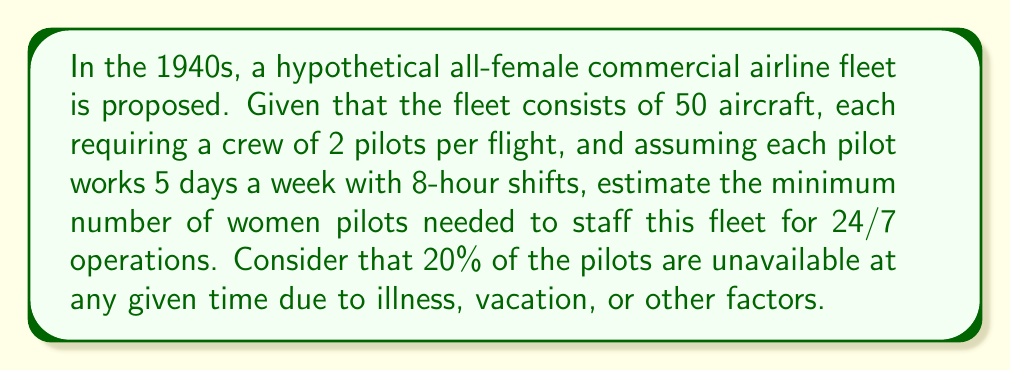Show me your answer to this math problem. 1. Calculate the total number of pilot positions per day:
   $$ \text{Total positions} = \text{Number of aircraft} \times \text{Pilots per aircraft} \times \text{Shifts per day} $$
   $$ \text{Total positions} = 50 \times 2 \times 3 = 300 \text{ positions per day} $$

2. Calculate the number of working days per week for each pilot:
   $$ \text{Working days per week} = 5 \text{ days} $$

3. Calculate the number of pilot positions needed per week:
   $$ \text{Weekly positions} = \text{Daily positions} \times 7 \text{ days} $$
   $$ \text{Weekly positions} = 300 \times 7 = 2100 \text{ positions per week} $$

4. Calculate the number of shifts each pilot can cover per week:
   $$ \text{Shifts per pilot per week} = \text{Working days per week} = 5 \text{ shifts} $$

5. Calculate the base number of pilots needed:
   $$ \text{Base number of pilots} = \frac{\text{Weekly positions}}{\text{Shifts per pilot per week}} $$
   $$ \text{Base number of pilots} = \frac{2100}{5} = 420 \text{ pilots} $$

6. Account for the 20% unavailability:
   $$ \text{Total pilots needed} = \frac{\text{Base number of pilots}}{(1 - \text{Unavailability rate})} $$
   $$ \text{Total pilots needed} = \frac{420}{(1 - 0.20)} = \frac{420}{0.80} = 525 \text{ pilots} $$

7. Round up to the nearest whole number:
   $$ \text{Minimum number of pilots} = \lceil 525 \rceil = 525 \text{ pilots} $$
Answer: 525 pilots 